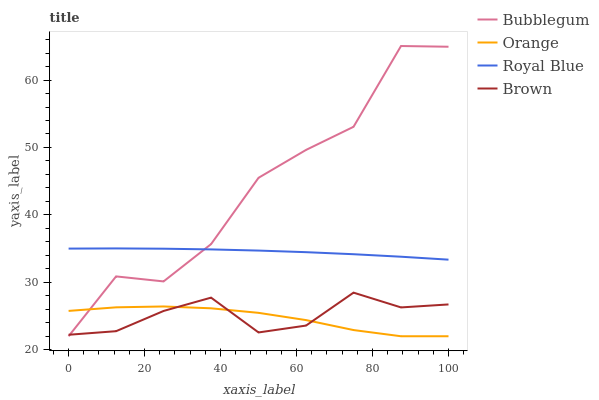Does Orange have the minimum area under the curve?
Answer yes or no. Yes. Does Bubblegum have the maximum area under the curve?
Answer yes or no. Yes. Does Royal Blue have the minimum area under the curve?
Answer yes or no. No. Does Royal Blue have the maximum area under the curve?
Answer yes or no. No. Is Royal Blue the smoothest?
Answer yes or no. Yes. Is Bubblegum the roughest?
Answer yes or no. Yes. Is Bubblegum the smoothest?
Answer yes or no. No. Is Royal Blue the roughest?
Answer yes or no. No. Does Orange have the lowest value?
Answer yes or no. Yes. Does Royal Blue have the lowest value?
Answer yes or no. No. Does Bubblegum have the highest value?
Answer yes or no. Yes. Does Royal Blue have the highest value?
Answer yes or no. No. Is Brown less than Royal Blue?
Answer yes or no. Yes. Is Royal Blue greater than Brown?
Answer yes or no. Yes. Does Orange intersect Bubblegum?
Answer yes or no. Yes. Is Orange less than Bubblegum?
Answer yes or no. No. Is Orange greater than Bubblegum?
Answer yes or no. No. Does Brown intersect Royal Blue?
Answer yes or no. No. 